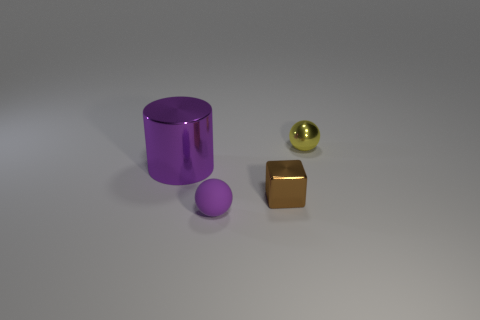Do the tiny yellow thing and the purple thing in front of the large purple shiny object have the same shape?
Offer a very short reply. Yes. Are there the same number of brown objects in front of the big cylinder and tiny purple matte objects in front of the small shiny block?
Ensure brevity in your answer.  Yes. What number of other objects are the same material as the tiny purple sphere?
Give a very brief answer. 0. How many rubber things are small red cylinders or yellow objects?
Your answer should be compact. 0. Is the shape of the purple thing that is to the right of the purple shiny object the same as  the yellow metal thing?
Your answer should be very brief. Yes. Is the number of big purple metal cylinders that are behind the tiny cube greater than the number of small red metal cylinders?
Your response must be concise. Yes. How many metallic things are to the left of the tiny metal ball and on the right side of the large metallic object?
Provide a short and direct response. 1. There is a tiny sphere right of the shiny thing in front of the big purple thing; what color is it?
Keep it short and to the point. Yellow. What number of large metal things are the same color as the matte ball?
Provide a short and direct response. 1. Do the large shiny cylinder and the small thing that is in front of the brown cube have the same color?
Offer a very short reply. Yes. 